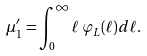Convert formula to latex. <formula><loc_0><loc_0><loc_500><loc_500>\mu _ { 1 } ^ { \prime } = \int _ { 0 } ^ { \infty } \ell \, \varphi _ { L } ( \ell ) d \ell .</formula> 